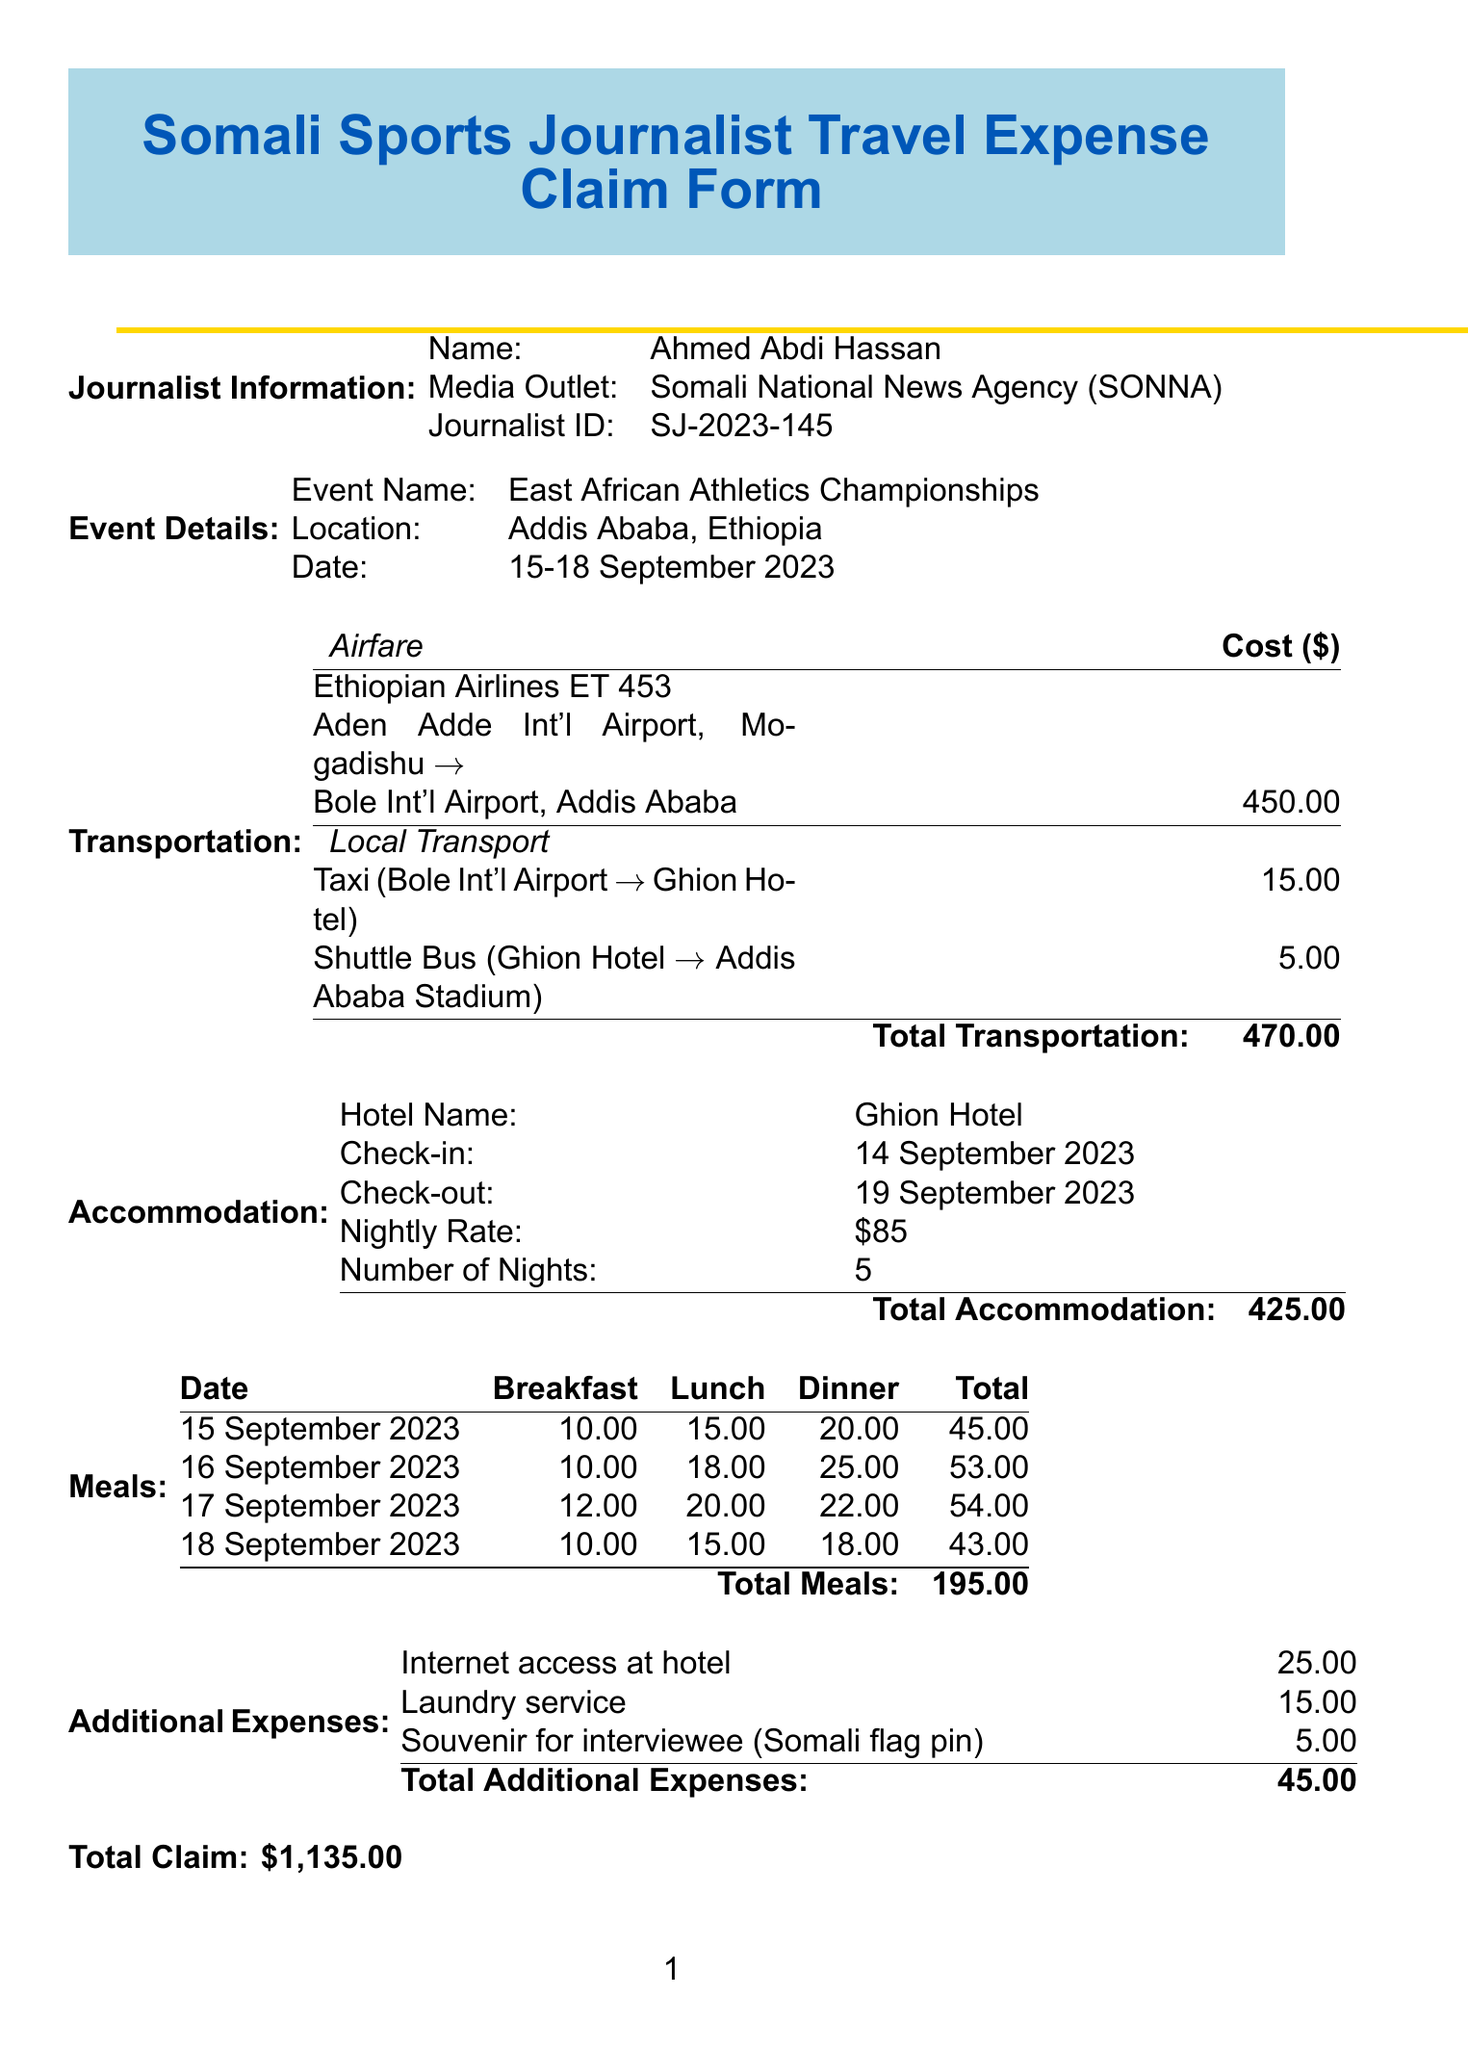What is the journalist's name? The journalist's name is listed in the document under Journalist Information.
Answer: Ahmed Abdi Hassan What is the location of the event? The location of the event is specified in the Event Details section of the document.
Answer: Addis Ababa, Ethiopia What was the cost of airfare? The airfare cost is explicitly mentioned in the Transportation section.
Answer: 450.00 How many nights did the journalist stay at the hotel? The number of nights is provided in the Accommodation section of the document.
Answer: 5 What is the total claim amount? The total claim amount is calculated as the sum of transportation, accommodation, meals, and additional expenses.
Answer: \$1,135.00 What date did the journalist check in to the hotel? The check-in date is indicated in the Accommodation section of the document.
Answer: 14 September 2023 How much did the meals cost in total? The total meals cost is summarised in the Meals section of the document.
Answer: 195.00 What additional expense was incurred for internet access? The additional expense for internet access is specified in the Additional Expenses section.
Answer: 25.00 Who is the approver of this claim? The name of the approver is mentioned at the end of the document under Signatures.
Answer: Farhiya Mohamud Ali 